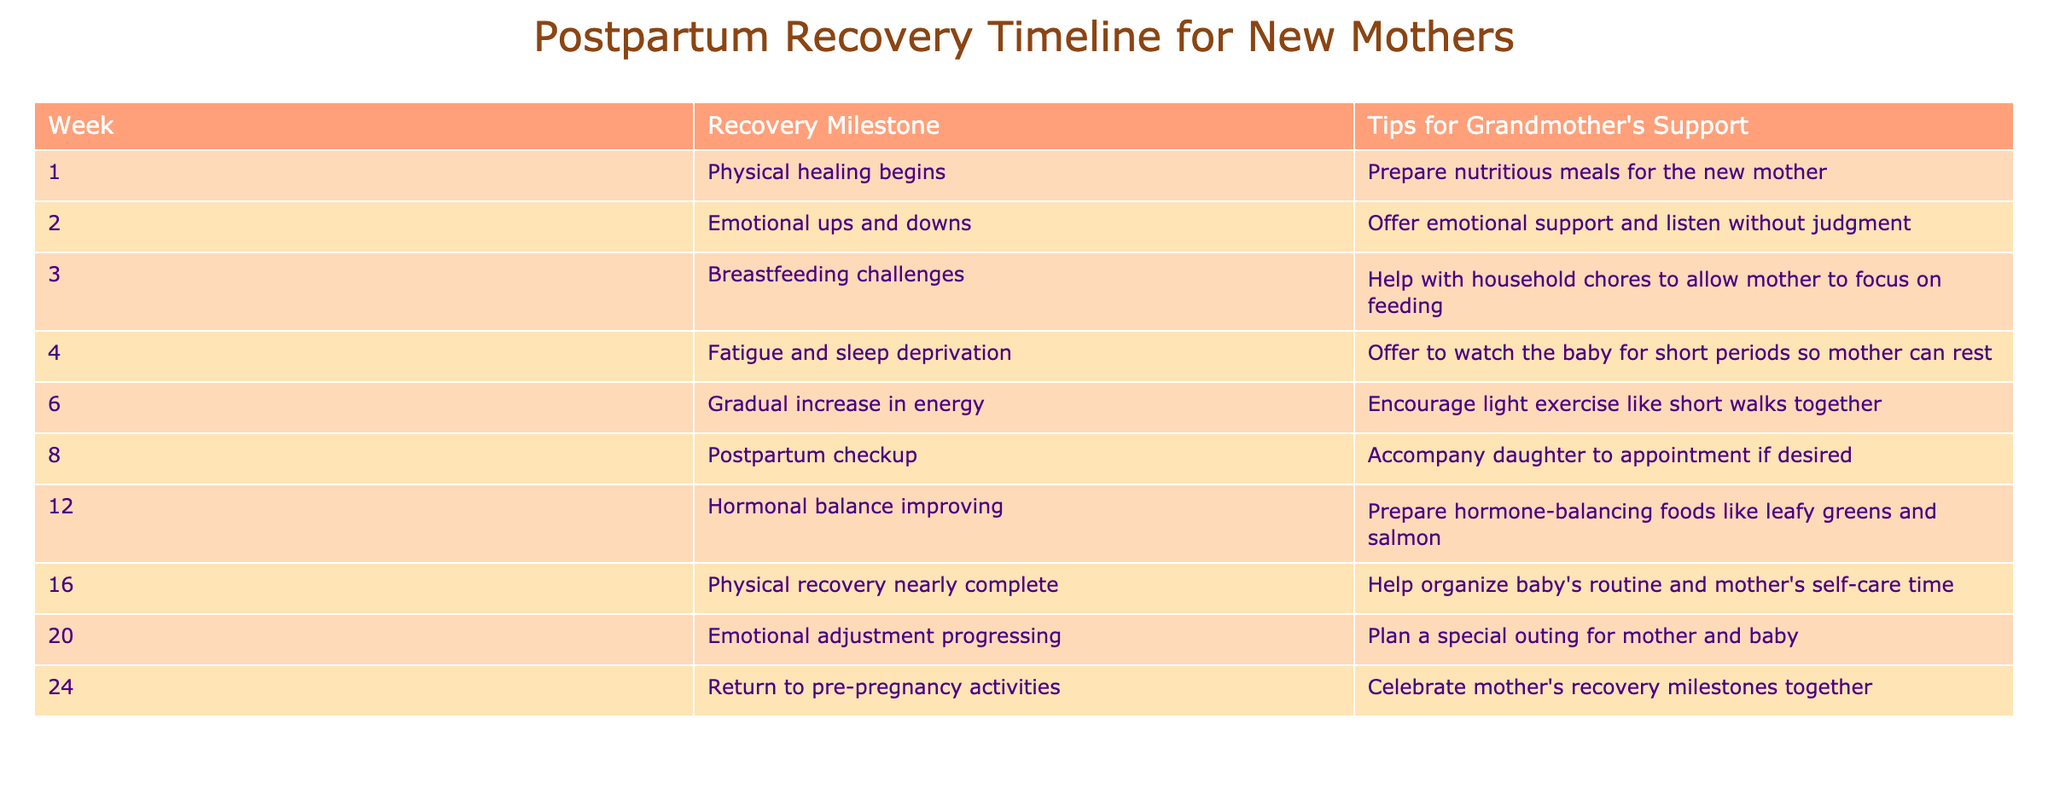What is the recovery milestone for week 4? According to the table, the recovery milestone for week 4 is "Fatigue and sleep deprivation."
Answer: Fatigue and sleep deprivation What tips for grandmother's support are suggested for week 2? The table indicates that the tip for grandmother's support in week 2 is to "Offer emotional support and listen without judgment."
Answer: Offer emotional support and listen without judgment How many weeks after childbirth does the postpartum checkup occur? The postpartum checkup occurs at week 8, which is 8 weeks after childbirth.
Answer: 8 weeks Is it true that by week 12, the hormonal balance is improving? Yes, the table states that hormonal balance is improving by week 12.
Answer: Yes What significant change occurs by week 20 regarding emotional adjustment? By week 20, the table shows that "Emotional adjustment progressing" occurs, indicating a positive change in the emotional state of the new mother.
Answer: Emotional adjustment progressing What tips are suggested for grandmothers to support the new mother at week 6? The recommended tip for grandmothers at week 6 is to "Encourage light exercise like short walks together."
Answer: Encourage light exercise like short walks together How does the recovery milestone change from week 1 to week 3? From week 1 to week 3, the recovery milestone shifts from "Physical healing begins" to "Breastfeeding challenges," indicating a transition from focusing on physical recovery to addressing breastfeeding issues.
Answer: From physical healing to breastfeeding challenges What is the median week for the physical recovery to be nearly complete? Physical recovery is nearly complete by week 16, which is the only value for this milestone and thus is also the median week for this category.
Answer: 16 What is one way grandmothers can help at week 8? The table suggests that grandmothers can "Accompany daughter to appointment if desired" as a form of support during week 8.
Answer: Accompany daughter to appointment if desired 